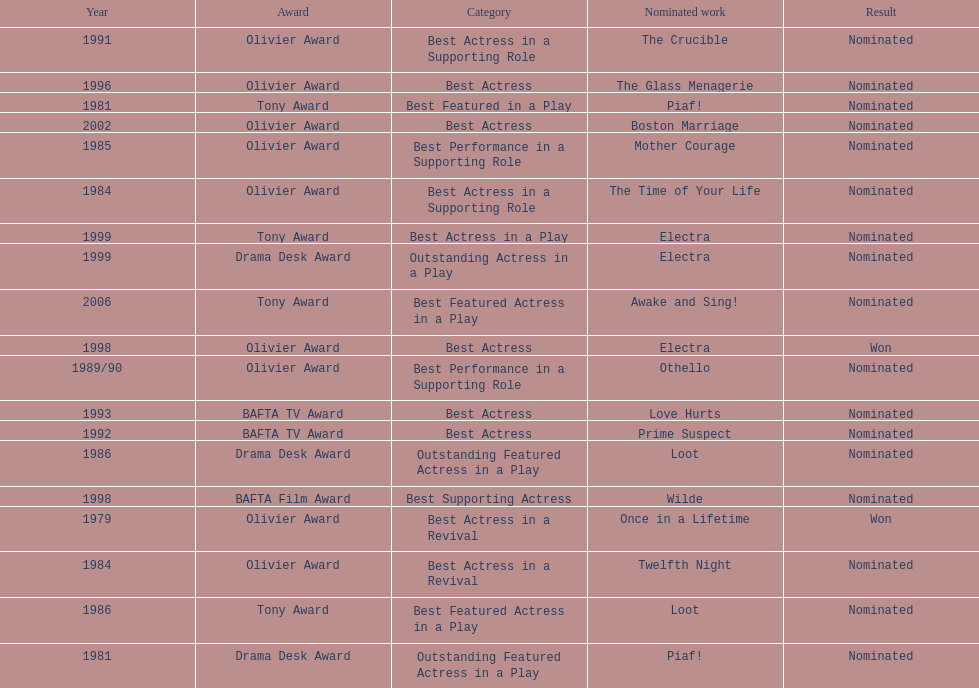Would you mind parsing the complete table? {'header': ['Year', 'Award', 'Category', 'Nominated work', 'Result'], 'rows': [['1991', 'Olivier Award', 'Best Actress in a Supporting Role', 'The Crucible', 'Nominated'], ['1996', 'Olivier Award', 'Best Actress', 'The Glass Menagerie', 'Nominated'], ['1981', 'Tony Award', 'Best Featured in a Play', 'Piaf!', 'Nominated'], ['2002', 'Olivier Award', 'Best Actress', 'Boston Marriage', 'Nominated'], ['1985', 'Olivier Award', 'Best Performance in a Supporting Role', 'Mother Courage', 'Nominated'], ['1984', 'Olivier Award', 'Best Actress in a Supporting Role', 'The Time of Your Life', 'Nominated'], ['1999', 'Tony Award', 'Best Actress in a Play', 'Electra', 'Nominated'], ['1999', 'Drama Desk Award', 'Outstanding Actress in a Play', 'Electra', 'Nominated'], ['2006', 'Tony Award', 'Best Featured Actress in a Play', 'Awake and Sing!', 'Nominated'], ['1998', 'Olivier Award', 'Best Actress', 'Electra', 'Won'], ['1989/90', 'Olivier Award', 'Best Performance in a Supporting Role', 'Othello', 'Nominated'], ['1993', 'BAFTA TV Award', 'Best Actress', 'Love Hurts', 'Nominated'], ['1992', 'BAFTA TV Award', 'Best Actress', 'Prime Suspect', 'Nominated'], ['1986', 'Drama Desk Award', 'Outstanding Featured Actress in a Play', 'Loot', 'Nominated'], ['1998', 'BAFTA Film Award', 'Best Supporting Actress', 'Wilde', 'Nominated'], ['1979', 'Olivier Award', 'Best Actress in a Revival', 'Once in a Lifetime', 'Won'], ['1984', 'Olivier Award', 'Best Actress in a Revival', 'Twelfth Night', 'Nominated'], ['1986', 'Tony Award', 'Best Featured Actress in a Play', 'Loot', 'Nominated'], ['1981', 'Drama Desk Award', 'Outstanding Featured Actress in a Play', 'Piaf!', 'Nominated']]} What play was wanamaker nominated for best actress in a revival in 1984? Twelfth Night. 